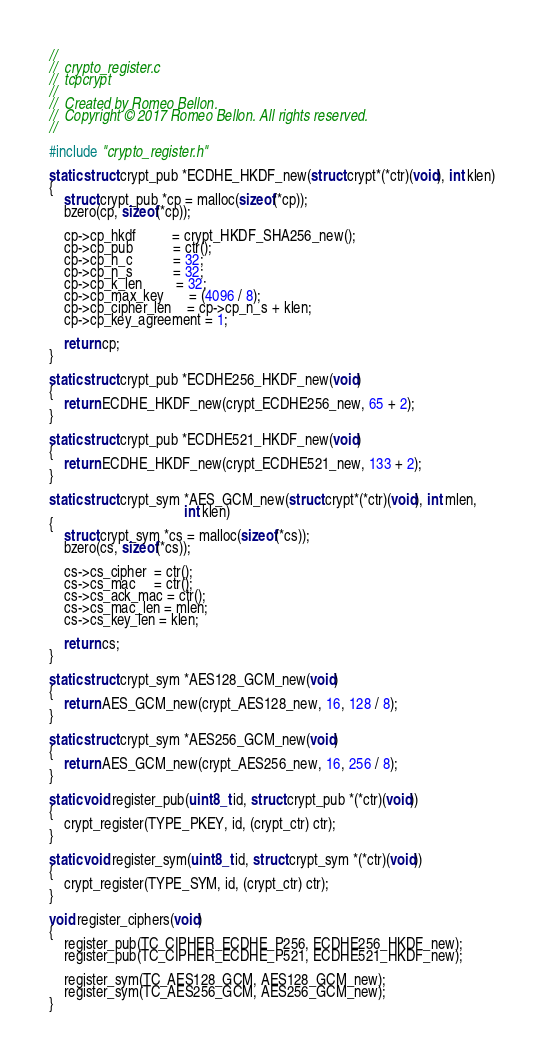<code> <loc_0><loc_0><loc_500><loc_500><_C_>//
//  crypto_register.c
//  tcpcrypt
//
//  Created by Romeo Bellon.
//  Copyright © 2017 Romeo Bellon. All rights reserved.
//

#include "crypto_register.h"

static struct crypt_pub *ECDHE_HKDF_new(struct crypt*(*ctr)(void), int klen)
{
    struct crypt_pub *cp = malloc(sizeof(*cp));
    bzero(cp, sizeof(*cp));
    
    cp->cp_hkdf          = crypt_HKDF_SHA256_new();
    cp->cp_pub           = ctr();
    cp->cp_n_c           = 32;
    cp->cp_n_s           = 32;
    cp->cp_k_len         = 32;
    cp->cp_max_key       = (4096 / 8);
    cp->cp_cipher_len    = cp->cp_n_s + klen;
    cp->cp_key_agreement = 1;
    
    return cp;
}

static struct crypt_pub *ECDHE256_HKDF_new(void)
{
    return ECDHE_HKDF_new(crypt_ECDHE256_new, 65 + 2);
}

static struct crypt_pub *ECDHE521_HKDF_new(void)
{
    return ECDHE_HKDF_new(crypt_ECDHE521_new, 133 + 2);
}

static struct crypt_sym *AES_GCM_new(struct crypt*(*ctr)(void), int mlen,
                                     int klen)
{
    struct crypt_sym *cs = malloc(sizeof(*cs));
    bzero(cs, sizeof(*cs));
    
    cs->cs_cipher  = ctr();
    cs->cs_mac     = ctr();
    cs->cs_ack_mac = ctr();
    cs->cs_mac_len = mlen;
    cs->cs_key_len = klen;
    
    return cs;
}

static struct crypt_sym *AES128_GCM_new(void)
{
    return AES_GCM_new(crypt_AES128_new, 16, 128 / 8);
}

static struct crypt_sym *AES256_GCM_new(void)
{
    return AES_GCM_new(crypt_AES256_new, 16, 256 / 8);
}

static void register_pub(uint8_t id, struct crypt_pub *(*ctr)(void))
{
    crypt_register(TYPE_PKEY, id, (crypt_ctr) ctr);
}

static void register_sym(uint8_t id, struct crypt_sym *(*ctr)(void))
{
    crypt_register(TYPE_SYM, id, (crypt_ctr) ctr);
}

void register_ciphers(void)
{
    register_pub(TC_CIPHER_ECDHE_P256, ECDHE256_HKDF_new);
    register_pub(TC_CIPHER_ECDHE_P521, ECDHE521_HKDF_new);
    
    register_sym(TC_AES128_GCM, AES128_GCM_new);
    register_sym(TC_AES256_GCM, AES256_GCM_new);
}
</code> 